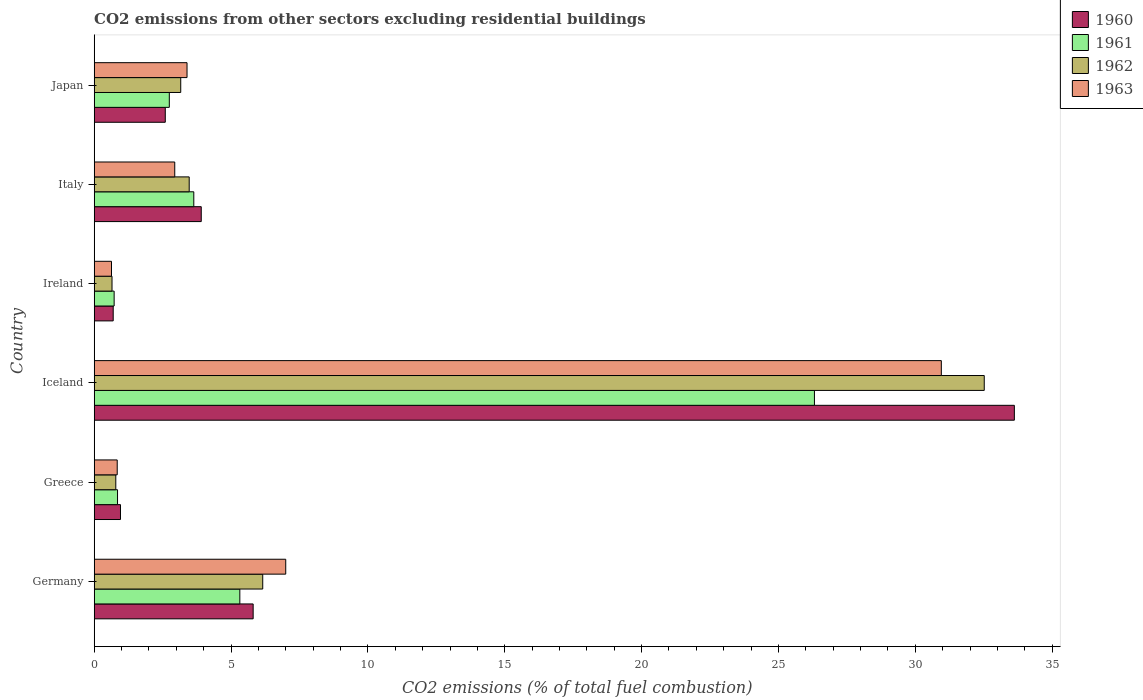How many groups of bars are there?
Keep it short and to the point. 6. Are the number of bars per tick equal to the number of legend labels?
Ensure brevity in your answer.  Yes. Are the number of bars on each tick of the Y-axis equal?
Give a very brief answer. Yes. How many bars are there on the 2nd tick from the top?
Give a very brief answer. 4. How many bars are there on the 2nd tick from the bottom?
Provide a succinct answer. 4. What is the label of the 4th group of bars from the top?
Keep it short and to the point. Iceland. What is the total CO2 emitted in 1962 in Greece?
Keep it short and to the point. 0.79. Across all countries, what is the maximum total CO2 emitted in 1960?
Your answer should be very brief. 33.62. Across all countries, what is the minimum total CO2 emitted in 1963?
Keep it short and to the point. 0.63. In which country was the total CO2 emitted in 1961 minimum?
Ensure brevity in your answer.  Ireland. What is the total total CO2 emitted in 1963 in the graph?
Your answer should be very brief. 45.76. What is the difference between the total CO2 emitted in 1961 in Greece and that in Italy?
Make the answer very short. -2.79. What is the difference between the total CO2 emitted in 1961 in Greece and the total CO2 emitted in 1962 in Germany?
Ensure brevity in your answer.  -5.31. What is the average total CO2 emitted in 1962 per country?
Offer a very short reply. 7.79. What is the difference between the total CO2 emitted in 1960 and total CO2 emitted in 1963 in Ireland?
Your answer should be very brief. 0.06. What is the ratio of the total CO2 emitted in 1962 in Greece to that in Japan?
Offer a terse response. 0.25. Is the difference between the total CO2 emitted in 1960 in Germany and Greece greater than the difference between the total CO2 emitted in 1963 in Germany and Greece?
Provide a succinct answer. No. What is the difference between the highest and the second highest total CO2 emitted in 1960?
Ensure brevity in your answer.  27.81. What is the difference between the highest and the lowest total CO2 emitted in 1961?
Offer a very short reply. 25.59. Is the sum of the total CO2 emitted in 1963 in Ireland and Japan greater than the maximum total CO2 emitted in 1962 across all countries?
Give a very brief answer. No. Is it the case that in every country, the sum of the total CO2 emitted in 1962 and total CO2 emitted in 1963 is greater than the sum of total CO2 emitted in 1961 and total CO2 emitted in 1960?
Offer a very short reply. No. What does the 4th bar from the top in Ireland represents?
Your answer should be compact. 1960. Is it the case that in every country, the sum of the total CO2 emitted in 1961 and total CO2 emitted in 1962 is greater than the total CO2 emitted in 1963?
Offer a very short reply. Yes. Are all the bars in the graph horizontal?
Make the answer very short. Yes. Are the values on the major ticks of X-axis written in scientific E-notation?
Provide a succinct answer. No. Does the graph contain any zero values?
Your answer should be very brief. No. Where does the legend appear in the graph?
Provide a short and direct response. Top right. How many legend labels are there?
Provide a short and direct response. 4. How are the legend labels stacked?
Make the answer very short. Vertical. What is the title of the graph?
Your answer should be very brief. CO2 emissions from other sectors excluding residential buildings. Does "1988" appear as one of the legend labels in the graph?
Make the answer very short. No. What is the label or title of the X-axis?
Your answer should be very brief. CO2 emissions (% of total fuel combustion). What is the label or title of the Y-axis?
Offer a terse response. Country. What is the CO2 emissions (% of total fuel combustion) in 1960 in Germany?
Provide a short and direct response. 5.81. What is the CO2 emissions (% of total fuel combustion) of 1961 in Germany?
Provide a short and direct response. 5.32. What is the CO2 emissions (% of total fuel combustion) in 1962 in Germany?
Provide a short and direct response. 6.16. What is the CO2 emissions (% of total fuel combustion) of 1963 in Germany?
Ensure brevity in your answer.  7. What is the CO2 emissions (% of total fuel combustion) of 1960 in Greece?
Provide a short and direct response. 0.96. What is the CO2 emissions (% of total fuel combustion) in 1961 in Greece?
Your answer should be very brief. 0.85. What is the CO2 emissions (% of total fuel combustion) in 1962 in Greece?
Your response must be concise. 0.79. What is the CO2 emissions (% of total fuel combustion) of 1963 in Greece?
Ensure brevity in your answer.  0.84. What is the CO2 emissions (% of total fuel combustion) of 1960 in Iceland?
Provide a succinct answer. 33.62. What is the CO2 emissions (% of total fuel combustion) of 1961 in Iceland?
Keep it short and to the point. 26.32. What is the CO2 emissions (% of total fuel combustion) of 1962 in Iceland?
Your answer should be very brief. 32.52. What is the CO2 emissions (% of total fuel combustion) of 1963 in Iceland?
Make the answer very short. 30.95. What is the CO2 emissions (% of total fuel combustion) in 1960 in Ireland?
Your answer should be compact. 0.69. What is the CO2 emissions (% of total fuel combustion) of 1961 in Ireland?
Your response must be concise. 0.73. What is the CO2 emissions (% of total fuel combustion) of 1962 in Ireland?
Keep it short and to the point. 0.65. What is the CO2 emissions (% of total fuel combustion) of 1963 in Ireland?
Your answer should be very brief. 0.63. What is the CO2 emissions (% of total fuel combustion) in 1960 in Italy?
Your answer should be compact. 3.91. What is the CO2 emissions (% of total fuel combustion) in 1961 in Italy?
Make the answer very short. 3.64. What is the CO2 emissions (% of total fuel combustion) of 1962 in Italy?
Offer a terse response. 3.47. What is the CO2 emissions (% of total fuel combustion) in 1963 in Italy?
Make the answer very short. 2.94. What is the CO2 emissions (% of total fuel combustion) in 1960 in Japan?
Provide a short and direct response. 2.6. What is the CO2 emissions (% of total fuel combustion) in 1961 in Japan?
Offer a very short reply. 2.74. What is the CO2 emissions (% of total fuel combustion) of 1962 in Japan?
Provide a short and direct response. 3.16. What is the CO2 emissions (% of total fuel combustion) in 1963 in Japan?
Keep it short and to the point. 3.39. Across all countries, what is the maximum CO2 emissions (% of total fuel combustion) in 1960?
Make the answer very short. 33.62. Across all countries, what is the maximum CO2 emissions (% of total fuel combustion) in 1961?
Offer a very short reply. 26.32. Across all countries, what is the maximum CO2 emissions (% of total fuel combustion) of 1962?
Make the answer very short. 32.52. Across all countries, what is the maximum CO2 emissions (% of total fuel combustion) in 1963?
Keep it short and to the point. 30.95. Across all countries, what is the minimum CO2 emissions (% of total fuel combustion) of 1960?
Give a very brief answer. 0.69. Across all countries, what is the minimum CO2 emissions (% of total fuel combustion) of 1961?
Your answer should be very brief. 0.73. Across all countries, what is the minimum CO2 emissions (% of total fuel combustion) in 1962?
Provide a short and direct response. 0.65. Across all countries, what is the minimum CO2 emissions (% of total fuel combustion) of 1963?
Your answer should be very brief. 0.63. What is the total CO2 emissions (% of total fuel combustion) in 1960 in the graph?
Ensure brevity in your answer.  47.59. What is the total CO2 emissions (% of total fuel combustion) of 1961 in the graph?
Your answer should be compact. 39.6. What is the total CO2 emissions (% of total fuel combustion) of 1962 in the graph?
Give a very brief answer. 46.75. What is the total CO2 emissions (% of total fuel combustion) of 1963 in the graph?
Provide a short and direct response. 45.76. What is the difference between the CO2 emissions (% of total fuel combustion) of 1960 in Germany and that in Greece?
Ensure brevity in your answer.  4.85. What is the difference between the CO2 emissions (% of total fuel combustion) of 1961 in Germany and that in Greece?
Provide a short and direct response. 4.47. What is the difference between the CO2 emissions (% of total fuel combustion) in 1962 in Germany and that in Greece?
Ensure brevity in your answer.  5.37. What is the difference between the CO2 emissions (% of total fuel combustion) in 1963 in Germany and that in Greece?
Give a very brief answer. 6.16. What is the difference between the CO2 emissions (% of total fuel combustion) of 1960 in Germany and that in Iceland?
Offer a terse response. -27.81. What is the difference between the CO2 emissions (% of total fuel combustion) in 1961 in Germany and that in Iceland?
Make the answer very short. -20.99. What is the difference between the CO2 emissions (% of total fuel combustion) in 1962 in Germany and that in Iceland?
Your answer should be very brief. -26.36. What is the difference between the CO2 emissions (% of total fuel combustion) of 1963 in Germany and that in Iceland?
Your answer should be compact. -23.95. What is the difference between the CO2 emissions (% of total fuel combustion) of 1960 in Germany and that in Ireland?
Your answer should be compact. 5.11. What is the difference between the CO2 emissions (% of total fuel combustion) of 1961 in Germany and that in Ireland?
Provide a short and direct response. 4.59. What is the difference between the CO2 emissions (% of total fuel combustion) in 1962 in Germany and that in Ireland?
Give a very brief answer. 5.51. What is the difference between the CO2 emissions (% of total fuel combustion) of 1963 in Germany and that in Ireland?
Your answer should be very brief. 6.37. What is the difference between the CO2 emissions (% of total fuel combustion) of 1960 in Germany and that in Italy?
Offer a very short reply. 1.9. What is the difference between the CO2 emissions (% of total fuel combustion) of 1961 in Germany and that in Italy?
Give a very brief answer. 1.68. What is the difference between the CO2 emissions (% of total fuel combustion) in 1962 in Germany and that in Italy?
Your response must be concise. 2.69. What is the difference between the CO2 emissions (% of total fuel combustion) in 1963 in Germany and that in Italy?
Offer a very short reply. 4.05. What is the difference between the CO2 emissions (% of total fuel combustion) of 1960 in Germany and that in Japan?
Offer a very short reply. 3.21. What is the difference between the CO2 emissions (% of total fuel combustion) of 1961 in Germany and that in Japan?
Keep it short and to the point. 2.58. What is the difference between the CO2 emissions (% of total fuel combustion) in 1962 in Germany and that in Japan?
Provide a short and direct response. 3. What is the difference between the CO2 emissions (% of total fuel combustion) in 1963 in Germany and that in Japan?
Offer a very short reply. 3.61. What is the difference between the CO2 emissions (% of total fuel combustion) in 1960 in Greece and that in Iceland?
Keep it short and to the point. -32.66. What is the difference between the CO2 emissions (% of total fuel combustion) of 1961 in Greece and that in Iceland?
Offer a terse response. -25.46. What is the difference between the CO2 emissions (% of total fuel combustion) in 1962 in Greece and that in Iceland?
Provide a succinct answer. -31.73. What is the difference between the CO2 emissions (% of total fuel combustion) in 1963 in Greece and that in Iceland?
Offer a terse response. -30.11. What is the difference between the CO2 emissions (% of total fuel combustion) in 1960 in Greece and that in Ireland?
Ensure brevity in your answer.  0.27. What is the difference between the CO2 emissions (% of total fuel combustion) of 1961 in Greece and that in Ireland?
Your response must be concise. 0.12. What is the difference between the CO2 emissions (% of total fuel combustion) of 1962 in Greece and that in Ireland?
Your answer should be very brief. 0.14. What is the difference between the CO2 emissions (% of total fuel combustion) in 1963 in Greece and that in Ireland?
Your answer should be very brief. 0.21. What is the difference between the CO2 emissions (% of total fuel combustion) of 1960 in Greece and that in Italy?
Keep it short and to the point. -2.95. What is the difference between the CO2 emissions (% of total fuel combustion) of 1961 in Greece and that in Italy?
Offer a very short reply. -2.79. What is the difference between the CO2 emissions (% of total fuel combustion) of 1962 in Greece and that in Italy?
Offer a very short reply. -2.68. What is the difference between the CO2 emissions (% of total fuel combustion) in 1963 in Greece and that in Italy?
Make the answer very short. -2.1. What is the difference between the CO2 emissions (% of total fuel combustion) of 1960 in Greece and that in Japan?
Your answer should be compact. -1.64. What is the difference between the CO2 emissions (% of total fuel combustion) of 1961 in Greece and that in Japan?
Keep it short and to the point. -1.89. What is the difference between the CO2 emissions (% of total fuel combustion) in 1962 in Greece and that in Japan?
Provide a succinct answer. -2.37. What is the difference between the CO2 emissions (% of total fuel combustion) of 1963 in Greece and that in Japan?
Make the answer very short. -2.55. What is the difference between the CO2 emissions (% of total fuel combustion) of 1960 in Iceland and that in Ireland?
Offer a very short reply. 32.93. What is the difference between the CO2 emissions (% of total fuel combustion) of 1961 in Iceland and that in Ireland?
Make the answer very short. 25.59. What is the difference between the CO2 emissions (% of total fuel combustion) of 1962 in Iceland and that in Ireland?
Your answer should be compact. 31.87. What is the difference between the CO2 emissions (% of total fuel combustion) of 1963 in Iceland and that in Ireland?
Make the answer very short. 30.32. What is the difference between the CO2 emissions (% of total fuel combustion) in 1960 in Iceland and that in Italy?
Your response must be concise. 29.71. What is the difference between the CO2 emissions (% of total fuel combustion) of 1961 in Iceland and that in Italy?
Give a very brief answer. 22.68. What is the difference between the CO2 emissions (% of total fuel combustion) of 1962 in Iceland and that in Italy?
Offer a terse response. 29.05. What is the difference between the CO2 emissions (% of total fuel combustion) of 1963 in Iceland and that in Italy?
Offer a terse response. 28.01. What is the difference between the CO2 emissions (% of total fuel combustion) of 1960 in Iceland and that in Japan?
Ensure brevity in your answer.  31.02. What is the difference between the CO2 emissions (% of total fuel combustion) of 1961 in Iceland and that in Japan?
Offer a very short reply. 23.57. What is the difference between the CO2 emissions (% of total fuel combustion) in 1962 in Iceland and that in Japan?
Your answer should be compact. 29.36. What is the difference between the CO2 emissions (% of total fuel combustion) of 1963 in Iceland and that in Japan?
Your response must be concise. 27.56. What is the difference between the CO2 emissions (% of total fuel combustion) of 1960 in Ireland and that in Italy?
Offer a very short reply. -3.22. What is the difference between the CO2 emissions (% of total fuel combustion) of 1961 in Ireland and that in Italy?
Provide a short and direct response. -2.91. What is the difference between the CO2 emissions (% of total fuel combustion) of 1962 in Ireland and that in Italy?
Your response must be concise. -2.82. What is the difference between the CO2 emissions (% of total fuel combustion) of 1963 in Ireland and that in Italy?
Make the answer very short. -2.31. What is the difference between the CO2 emissions (% of total fuel combustion) of 1960 in Ireland and that in Japan?
Make the answer very short. -1.9. What is the difference between the CO2 emissions (% of total fuel combustion) in 1961 in Ireland and that in Japan?
Your response must be concise. -2.02. What is the difference between the CO2 emissions (% of total fuel combustion) in 1962 in Ireland and that in Japan?
Offer a very short reply. -2.51. What is the difference between the CO2 emissions (% of total fuel combustion) of 1963 in Ireland and that in Japan?
Make the answer very short. -2.76. What is the difference between the CO2 emissions (% of total fuel combustion) of 1960 in Italy and that in Japan?
Provide a short and direct response. 1.31. What is the difference between the CO2 emissions (% of total fuel combustion) of 1961 in Italy and that in Japan?
Your answer should be compact. 0.89. What is the difference between the CO2 emissions (% of total fuel combustion) of 1962 in Italy and that in Japan?
Provide a succinct answer. 0.31. What is the difference between the CO2 emissions (% of total fuel combustion) in 1963 in Italy and that in Japan?
Ensure brevity in your answer.  -0.45. What is the difference between the CO2 emissions (% of total fuel combustion) of 1960 in Germany and the CO2 emissions (% of total fuel combustion) of 1961 in Greece?
Offer a very short reply. 4.96. What is the difference between the CO2 emissions (% of total fuel combustion) of 1960 in Germany and the CO2 emissions (% of total fuel combustion) of 1962 in Greece?
Give a very brief answer. 5.02. What is the difference between the CO2 emissions (% of total fuel combustion) of 1960 in Germany and the CO2 emissions (% of total fuel combustion) of 1963 in Greece?
Offer a terse response. 4.97. What is the difference between the CO2 emissions (% of total fuel combustion) of 1961 in Germany and the CO2 emissions (% of total fuel combustion) of 1962 in Greece?
Keep it short and to the point. 4.53. What is the difference between the CO2 emissions (% of total fuel combustion) of 1961 in Germany and the CO2 emissions (% of total fuel combustion) of 1963 in Greece?
Make the answer very short. 4.48. What is the difference between the CO2 emissions (% of total fuel combustion) of 1962 in Germany and the CO2 emissions (% of total fuel combustion) of 1963 in Greece?
Your response must be concise. 5.32. What is the difference between the CO2 emissions (% of total fuel combustion) of 1960 in Germany and the CO2 emissions (% of total fuel combustion) of 1961 in Iceland?
Provide a short and direct response. -20.51. What is the difference between the CO2 emissions (% of total fuel combustion) in 1960 in Germany and the CO2 emissions (% of total fuel combustion) in 1962 in Iceland?
Provide a succinct answer. -26.71. What is the difference between the CO2 emissions (% of total fuel combustion) in 1960 in Germany and the CO2 emissions (% of total fuel combustion) in 1963 in Iceland?
Provide a succinct answer. -25.14. What is the difference between the CO2 emissions (% of total fuel combustion) of 1961 in Germany and the CO2 emissions (% of total fuel combustion) of 1962 in Iceland?
Your answer should be very brief. -27.2. What is the difference between the CO2 emissions (% of total fuel combustion) of 1961 in Germany and the CO2 emissions (% of total fuel combustion) of 1963 in Iceland?
Offer a very short reply. -25.63. What is the difference between the CO2 emissions (% of total fuel combustion) in 1962 in Germany and the CO2 emissions (% of total fuel combustion) in 1963 in Iceland?
Provide a short and direct response. -24.79. What is the difference between the CO2 emissions (% of total fuel combustion) of 1960 in Germany and the CO2 emissions (% of total fuel combustion) of 1961 in Ireland?
Provide a short and direct response. 5.08. What is the difference between the CO2 emissions (% of total fuel combustion) in 1960 in Germany and the CO2 emissions (% of total fuel combustion) in 1962 in Ireland?
Make the answer very short. 5.16. What is the difference between the CO2 emissions (% of total fuel combustion) of 1960 in Germany and the CO2 emissions (% of total fuel combustion) of 1963 in Ireland?
Keep it short and to the point. 5.18. What is the difference between the CO2 emissions (% of total fuel combustion) of 1961 in Germany and the CO2 emissions (% of total fuel combustion) of 1962 in Ireland?
Offer a very short reply. 4.67. What is the difference between the CO2 emissions (% of total fuel combustion) in 1961 in Germany and the CO2 emissions (% of total fuel combustion) in 1963 in Ireland?
Offer a terse response. 4.69. What is the difference between the CO2 emissions (% of total fuel combustion) in 1962 in Germany and the CO2 emissions (% of total fuel combustion) in 1963 in Ireland?
Ensure brevity in your answer.  5.53. What is the difference between the CO2 emissions (% of total fuel combustion) of 1960 in Germany and the CO2 emissions (% of total fuel combustion) of 1961 in Italy?
Make the answer very short. 2.17. What is the difference between the CO2 emissions (% of total fuel combustion) of 1960 in Germany and the CO2 emissions (% of total fuel combustion) of 1962 in Italy?
Provide a short and direct response. 2.34. What is the difference between the CO2 emissions (% of total fuel combustion) of 1960 in Germany and the CO2 emissions (% of total fuel combustion) of 1963 in Italy?
Ensure brevity in your answer.  2.86. What is the difference between the CO2 emissions (% of total fuel combustion) of 1961 in Germany and the CO2 emissions (% of total fuel combustion) of 1962 in Italy?
Your response must be concise. 1.85. What is the difference between the CO2 emissions (% of total fuel combustion) of 1961 in Germany and the CO2 emissions (% of total fuel combustion) of 1963 in Italy?
Your answer should be very brief. 2.38. What is the difference between the CO2 emissions (% of total fuel combustion) of 1962 in Germany and the CO2 emissions (% of total fuel combustion) of 1963 in Italy?
Offer a very short reply. 3.21. What is the difference between the CO2 emissions (% of total fuel combustion) in 1960 in Germany and the CO2 emissions (% of total fuel combustion) in 1961 in Japan?
Ensure brevity in your answer.  3.06. What is the difference between the CO2 emissions (% of total fuel combustion) in 1960 in Germany and the CO2 emissions (% of total fuel combustion) in 1962 in Japan?
Keep it short and to the point. 2.65. What is the difference between the CO2 emissions (% of total fuel combustion) in 1960 in Germany and the CO2 emissions (% of total fuel combustion) in 1963 in Japan?
Your answer should be very brief. 2.42. What is the difference between the CO2 emissions (% of total fuel combustion) of 1961 in Germany and the CO2 emissions (% of total fuel combustion) of 1962 in Japan?
Make the answer very short. 2.16. What is the difference between the CO2 emissions (% of total fuel combustion) in 1961 in Germany and the CO2 emissions (% of total fuel combustion) in 1963 in Japan?
Your answer should be compact. 1.93. What is the difference between the CO2 emissions (% of total fuel combustion) in 1962 in Germany and the CO2 emissions (% of total fuel combustion) in 1963 in Japan?
Give a very brief answer. 2.77. What is the difference between the CO2 emissions (% of total fuel combustion) of 1960 in Greece and the CO2 emissions (% of total fuel combustion) of 1961 in Iceland?
Make the answer very short. -25.36. What is the difference between the CO2 emissions (% of total fuel combustion) of 1960 in Greece and the CO2 emissions (% of total fuel combustion) of 1962 in Iceland?
Provide a short and direct response. -31.56. What is the difference between the CO2 emissions (% of total fuel combustion) of 1960 in Greece and the CO2 emissions (% of total fuel combustion) of 1963 in Iceland?
Provide a succinct answer. -29.99. What is the difference between the CO2 emissions (% of total fuel combustion) in 1961 in Greece and the CO2 emissions (% of total fuel combustion) in 1962 in Iceland?
Make the answer very short. -31.67. What is the difference between the CO2 emissions (% of total fuel combustion) in 1961 in Greece and the CO2 emissions (% of total fuel combustion) in 1963 in Iceland?
Offer a very short reply. -30.1. What is the difference between the CO2 emissions (% of total fuel combustion) in 1962 in Greece and the CO2 emissions (% of total fuel combustion) in 1963 in Iceland?
Keep it short and to the point. -30.16. What is the difference between the CO2 emissions (% of total fuel combustion) in 1960 in Greece and the CO2 emissions (% of total fuel combustion) in 1961 in Ireland?
Keep it short and to the point. 0.23. What is the difference between the CO2 emissions (% of total fuel combustion) in 1960 in Greece and the CO2 emissions (% of total fuel combustion) in 1962 in Ireland?
Offer a very short reply. 0.31. What is the difference between the CO2 emissions (% of total fuel combustion) in 1960 in Greece and the CO2 emissions (% of total fuel combustion) in 1963 in Ireland?
Make the answer very short. 0.33. What is the difference between the CO2 emissions (% of total fuel combustion) in 1961 in Greece and the CO2 emissions (% of total fuel combustion) in 1962 in Ireland?
Keep it short and to the point. 0.2. What is the difference between the CO2 emissions (% of total fuel combustion) of 1961 in Greece and the CO2 emissions (% of total fuel combustion) of 1963 in Ireland?
Provide a succinct answer. 0.22. What is the difference between the CO2 emissions (% of total fuel combustion) of 1962 in Greece and the CO2 emissions (% of total fuel combustion) of 1963 in Ireland?
Ensure brevity in your answer.  0.16. What is the difference between the CO2 emissions (% of total fuel combustion) in 1960 in Greece and the CO2 emissions (% of total fuel combustion) in 1961 in Italy?
Provide a succinct answer. -2.68. What is the difference between the CO2 emissions (% of total fuel combustion) of 1960 in Greece and the CO2 emissions (% of total fuel combustion) of 1962 in Italy?
Ensure brevity in your answer.  -2.51. What is the difference between the CO2 emissions (% of total fuel combustion) in 1960 in Greece and the CO2 emissions (% of total fuel combustion) in 1963 in Italy?
Make the answer very short. -1.98. What is the difference between the CO2 emissions (% of total fuel combustion) in 1961 in Greece and the CO2 emissions (% of total fuel combustion) in 1962 in Italy?
Offer a terse response. -2.62. What is the difference between the CO2 emissions (% of total fuel combustion) in 1961 in Greece and the CO2 emissions (% of total fuel combustion) in 1963 in Italy?
Keep it short and to the point. -2.09. What is the difference between the CO2 emissions (% of total fuel combustion) in 1962 in Greece and the CO2 emissions (% of total fuel combustion) in 1963 in Italy?
Provide a succinct answer. -2.15. What is the difference between the CO2 emissions (% of total fuel combustion) of 1960 in Greece and the CO2 emissions (% of total fuel combustion) of 1961 in Japan?
Ensure brevity in your answer.  -1.78. What is the difference between the CO2 emissions (% of total fuel combustion) of 1960 in Greece and the CO2 emissions (% of total fuel combustion) of 1962 in Japan?
Make the answer very short. -2.2. What is the difference between the CO2 emissions (% of total fuel combustion) of 1960 in Greece and the CO2 emissions (% of total fuel combustion) of 1963 in Japan?
Keep it short and to the point. -2.43. What is the difference between the CO2 emissions (% of total fuel combustion) of 1961 in Greece and the CO2 emissions (% of total fuel combustion) of 1962 in Japan?
Offer a very short reply. -2.31. What is the difference between the CO2 emissions (% of total fuel combustion) in 1961 in Greece and the CO2 emissions (% of total fuel combustion) in 1963 in Japan?
Your answer should be compact. -2.54. What is the difference between the CO2 emissions (% of total fuel combustion) in 1962 in Greece and the CO2 emissions (% of total fuel combustion) in 1963 in Japan?
Give a very brief answer. -2.6. What is the difference between the CO2 emissions (% of total fuel combustion) of 1960 in Iceland and the CO2 emissions (% of total fuel combustion) of 1961 in Ireland?
Provide a short and direct response. 32.89. What is the difference between the CO2 emissions (% of total fuel combustion) of 1960 in Iceland and the CO2 emissions (% of total fuel combustion) of 1962 in Ireland?
Keep it short and to the point. 32.97. What is the difference between the CO2 emissions (% of total fuel combustion) of 1960 in Iceland and the CO2 emissions (% of total fuel combustion) of 1963 in Ireland?
Offer a very short reply. 32.99. What is the difference between the CO2 emissions (% of total fuel combustion) in 1961 in Iceland and the CO2 emissions (% of total fuel combustion) in 1962 in Ireland?
Give a very brief answer. 25.66. What is the difference between the CO2 emissions (% of total fuel combustion) in 1961 in Iceland and the CO2 emissions (% of total fuel combustion) in 1963 in Ireland?
Give a very brief answer. 25.68. What is the difference between the CO2 emissions (% of total fuel combustion) in 1962 in Iceland and the CO2 emissions (% of total fuel combustion) in 1963 in Ireland?
Provide a succinct answer. 31.89. What is the difference between the CO2 emissions (% of total fuel combustion) in 1960 in Iceland and the CO2 emissions (% of total fuel combustion) in 1961 in Italy?
Provide a succinct answer. 29.98. What is the difference between the CO2 emissions (% of total fuel combustion) in 1960 in Iceland and the CO2 emissions (% of total fuel combustion) in 1962 in Italy?
Provide a short and direct response. 30.15. What is the difference between the CO2 emissions (% of total fuel combustion) of 1960 in Iceland and the CO2 emissions (% of total fuel combustion) of 1963 in Italy?
Offer a very short reply. 30.68. What is the difference between the CO2 emissions (% of total fuel combustion) of 1961 in Iceland and the CO2 emissions (% of total fuel combustion) of 1962 in Italy?
Provide a succinct answer. 22.84. What is the difference between the CO2 emissions (% of total fuel combustion) in 1961 in Iceland and the CO2 emissions (% of total fuel combustion) in 1963 in Italy?
Offer a terse response. 23.37. What is the difference between the CO2 emissions (% of total fuel combustion) of 1962 in Iceland and the CO2 emissions (% of total fuel combustion) of 1963 in Italy?
Provide a succinct answer. 29.58. What is the difference between the CO2 emissions (% of total fuel combustion) of 1960 in Iceland and the CO2 emissions (% of total fuel combustion) of 1961 in Japan?
Make the answer very short. 30.88. What is the difference between the CO2 emissions (% of total fuel combustion) of 1960 in Iceland and the CO2 emissions (% of total fuel combustion) of 1962 in Japan?
Make the answer very short. 30.46. What is the difference between the CO2 emissions (% of total fuel combustion) of 1960 in Iceland and the CO2 emissions (% of total fuel combustion) of 1963 in Japan?
Ensure brevity in your answer.  30.23. What is the difference between the CO2 emissions (% of total fuel combustion) in 1961 in Iceland and the CO2 emissions (% of total fuel combustion) in 1962 in Japan?
Offer a very short reply. 23.15. What is the difference between the CO2 emissions (% of total fuel combustion) in 1961 in Iceland and the CO2 emissions (% of total fuel combustion) in 1963 in Japan?
Your answer should be very brief. 22.92. What is the difference between the CO2 emissions (% of total fuel combustion) of 1962 in Iceland and the CO2 emissions (% of total fuel combustion) of 1963 in Japan?
Offer a terse response. 29.13. What is the difference between the CO2 emissions (% of total fuel combustion) of 1960 in Ireland and the CO2 emissions (% of total fuel combustion) of 1961 in Italy?
Offer a very short reply. -2.94. What is the difference between the CO2 emissions (% of total fuel combustion) in 1960 in Ireland and the CO2 emissions (% of total fuel combustion) in 1962 in Italy?
Offer a terse response. -2.78. What is the difference between the CO2 emissions (% of total fuel combustion) of 1960 in Ireland and the CO2 emissions (% of total fuel combustion) of 1963 in Italy?
Ensure brevity in your answer.  -2.25. What is the difference between the CO2 emissions (% of total fuel combustion) in 1961 in Ireland and the CO2 emissions (% of total fuel combustion) in 1962 in Italy?
Make the answer very short. -2.74. What is the difference between the CO2 emissions (% of total fuel combustion) of 1961 in Ireland and the CO2 emissions (% of total fuel combustion) of 1963 in Italy?
Ensure brevity in your answer.  -2.21. What is the difference between the CO2 emissions (% of total fuel combustion) of 1962 in Ireland and the CO2 emissions (% of total fuel combustion) of 1963 in Italy?
Offer a very short reply. -2.29. What is the difference between the CO2 emissions (% of total fuel combustion) of 1960 in Ireland and the CO2 emissions (% of total fuel combustion) of 1961 in Japan?
Offer a very short reply. -2.05. What is the difference between the CO2 emissions (% of total fuel combustion) in 1960 in Ireland and the CO2 emissions (% of total fuel combustion) in 1962 in Japan?
Offer a very short reply. -2.47. What is the difference between the CO2 emissions (% of total fuel combustion) in 1960 in Ireland and the CO2 emissions (% of total fuel combustion) in 1963 in Japan?
Give a very brief answer. -2.7. What is the difference between the CO2 emissions (% of total fuel combustion) of 1961 in Ireland and the CO2 emissions (% of total fuel combustion) of 1962 in Japan?
Make the answer very short. -2.43. What is the difference between the CO2 emissions (% of total fuel combustion) of 1961 in Ireland and the CO2 emissions (% of total fuel combustion) of 1963 in Japan?
Provide a succinct answer. -2.66. What is the difference between the CO2 emissions (% of total fuel combustion) of 1962 in Ireland and the CO2 emissions (% of total fuel combustion) of 1963 in Japan?
Offer a very short reply. -2.74. What is the difference between the CO2 emissions (% of total fuel combustion) in 1960 in Italy and the CO2 emissions (% of total fuel combustion) in 1961 in Japan?
Your answer should be very brief. 1.17. What is the difference between the CO2 emissions (% of total fuel combustion) in 1960 in Italy and the CO2 emissions (% of total fuel combustion) in 1962 in Japan?
Provide a succinct answer. 0.75. What is the difference between the CO2 emissions (% of total fuel combustion) in 1960 in Italy and the CO2 emissions (% of total fuel combustion) in 1963 in Japan?
Provide a succinct answer. 0.52. What is the difference between the CO2 emissions (% of total fuel combustion) of 1961 in Italy and the CO2 emissions (% of total fuel combustion) of 1962 in Japan?
Give a very brief answer. 0.48. What is the difference between the CO2 emissions (% of total fuel combustion) in 1961 in Italy and the CO2 emissions (% of total fuel combustion) in 1963 in Japan?
Your response must be concise. 0.25. What is the difference between the CO2 emissions (% of total fuel combustion) in 1962 in Italy and the CO2 emissions (% of total fuel combustion) in 1963 in Japan?
Your response must be concise. 0.08. What is the average CO2 emissions (% of total fuel combustion) of 1960 per country?
Your response must be concise. 7.93. What is the average CO2 emissions (% of total fuel combustion) in 1961 per country?
Make the answer very short. 6.6. What is the average CO2 emissions (% of total fuel combustion) of 1962 per country?
Give a very brief answer. 7.79. What is the average CO2 emissions (% of total fuel combustion) of 1963 per country?
Keep it short and to the point. 7.63. What is the difference between the CO2 emissions (% of total fuel combustion) of 1960 and CO2 emissions (% of total fuel combustion) of 1961 in Germany?
Your response must be concise. 0.49. What is the difference between the CO2 emissions (% of total fuel combustion) in 1960 and CO2 emissions (% of total fuel combustion) in 1962 in Germany?
Provide a short and direct response. -0.35. What is the difference between the CO2 emissions (% of total fuel combustion) in 1960 and CO2 emissions (% of total fuel combustion) in 1963 in Germany?
Offer a terse response. -1.19. What is the difference between the CO2 emissions (% of total fuel combustion) of 1961 and CO2 emissions (% of total fuel combustion) of 1962 in Germany?
Ensure brevity in your answer.  -0.84. What is the difference between the CO2 emissions (% of total fuel combustion) in 1961 and CO2 emissions (% of total fuel combustion) in 1963 in Germany?
Your answer should be very brief. -1.68. What is the difference between the CO2 emissions (% of total fuel combustion) in 1962 and CO2 emissions (% of total fuel combustion) in 1963 in Germany?
Offer a terse response. -0.84. What is the difference between the CO2 emissions (% of total fuel combustion) of 1960 and CO2 emissions (% of total fuel combustion) of 1961 in Greece?
Make the answer very short. 0.11. What is the difference between the CO2 emissions (% of total fuel combustion) of 1960 and CO2 emissions (% of total fuel combustion) of 1962 in Greece?
Offer a terse response. 0.17. What is the difference between the CO2 emissions (% of total fuel combustion) of 1960 and CO2 emissions (% of total fuel combustion) of 1963 in Greece?
Provide a succinct answer. 0.12. What is the difference between the CO2 emissions (% of total fuel combustion) of 1961 and CO2 emissions (% of total fuel combustion) of 1962 in Greece?
Give a very brief answer. 0.06. What is the difference between the CO2 emissions (% of total fuel combustion) in 1961 and CO2 emissions (% of total fuel combustion) in 1963 in Greece?
Ensure brevity in your answer.  0.01. What is the difference between the CO2 emissions (% of total fuel combustion) in 1962 and CO2 emissions (% of total fuel combustion) in 1963 in Greece?
Make the answer very short. -0.05. What is the difference between the CO2 emissions (% of total fuel combustion) of 1960 and CO2 emissions (% of total fuel combustion) of 1961 in Iceland?
Keep it short and to the point. 7.3. What is the difference between the CO2 emissions (% of total fuel combustion) in 1960 and CO2 emissions (% of total fuel combustion) in 1962 in Iceland?
Provide a short and direct response. 1.1. What is the difference between the CO2 emissions (% of total fuel combustion) of 1960 and CO2 emissions (% of total fuel combustion) of 1963 in Iceland?
Provide a succinct answer. 2.67. What is the difference between the CO2 emissions (% of total fuel combustion) of 1961 and CO2 emissions (% of total fuel combustion) of 1962 in Iceland?
Provide a short and direct response. -6.2. What is the difference between the CO2 emissions (% of total fuel combustion) of 1961 and CO2 emissions (% of total fuel combustion) of 1963 in Iceland?
Provide a short and direct response. -4.64. What is the difference between the CO2 emissions (% of total fuel combustion) in 1962 and CO2 emissions (% of total fuel combustion) in 1963 in Iceland?
Keep it short and to the point. 1.57. What is the difference between the CO2 emissions (% of total fuel combustion) of 1960 and CO2 emissions (% of total fuel combustion) of 1961 in Ireland?
Your answer should be compact. -0.03. What is the difference between the CO2 emissions (% of total fuel combustion) in 1960 and CO2 emissions (% of total fuel combustion) in 1962 in Ireland?
Your answer should be very brief. 0.04. What is the difference between the CO2 emissions (% of total fuel combustion) of 1960 and CO2 emissions (% of total fuel combustion) of 1963 in Ireland?
Your answer should be very brief. 0.06. What is the difference between the CO2 emissions (% of total fuel combustion) of 1961 and CO2 emissions (% of total fuel combustion) of 1962 in Ireland?
Ensure brevity in your answer.  0.08. What is the difference between the CO2 emissions (% of total fuel combustion) in 1961 and CO2 emissions (% of total fuel combustion) in 1963 in Ireland?
Provide a short and direct response. 0.1. What is the difference between the CO2 emissions (% of total fuel combustion) of 1962 and CO2 emissions (% of total fuel combustion) of 1963 in Ireland?
Offer a very short reply. 0.02. What is the difference between the CO2 emissions (% of total fuel combustion) in 1960 and CO2 emissions (% of total fuel combustion) in 1961 in Italy?
Provide a short and direct response. 0.27. What is the difference between the CO2 emissions (% of total fuel combustion) of 1960 and CO2 emissions (% of total fuel combustion) of 1962 in Italy?
Offer a terse response. 0.44. What is the difference between the CO2 emissions (% of total fuel combustion) of 1961 and CO2 emissions (% of total fuel combustion) of 1962 in Italy?
Make the answer very short. 0.17. What is the difference between the CO2 emissions (% of total fuel combustion) of 1961 and CO2 emissions (% of total fuel combustion) of 1963 in Italy?
Provide a short and direct response. 0.7. What is the difference between the CO2 emissions (% of total fuel combustion) of 1962 and CO2 emissions (% of total fuel combustion) of 1963 in Italy?
Provide a succinct answer. 0.53. What is the difference between the CO2 emissions (% of total fuel combustion) of 1960 and CO2 emissions (% of total fuel combustion) of 1961 in Japan?
Your answer should be compact. -0.15. What is the difference between the CO2 emissions (% of total fuel combustion) in 1960 and CO2 emissions (% of total fuel combustion) in 1962 in Japan?
Provide a succinct answer. -0.56. What is the difference between the CO2 emissions (% of total fuel combustion) in 1960 and CO2 emissions (% of total fuel combustion) in 1963 in Japan?
Provide a succinct answer. -0.79. What is the difference between the CO2 emissions (% of total fuel combustion) in 1961 and CO2 emissions (% of total fuel combustion) in 1962 in Japan?
Make the answer very short. -0.42. What is the difference between the CO2 emissions (% of total fuel combustion) in 1961 and CO2 emissions (% of total fuel combustion) in 1963 in Japan?
Ensure brevity in your answer.  -0.65. What is the difference between the CO2 emissions (% of total fuel combustion) in 1962 and CO2 emissions (% of total fuel combustion) in 1963 in Japan?
Make the answer very short. -0.23. What is the ratio of the CO2 emissions (% of total fuel combustion) of 1960 in Germany to that in Greece?
Your answer should be very brief. 6.05. What is the ratio of the CO2 emissions (% of total fuel combustion) of 1961 in Germany to that in Greece?
Offer a very short reply. 6.24. What is the ratio of the CO2 emissions (% of total fuel combustion) of 1962 in Germany to that in Greece?
Provide a succinct answer. 7.8. What is the ratio of the CO2 emissions (% of total fuel combustion) in 1963 in Germany to that in Greece?
Offer a terse response. 8.32. What is the ratio of the CO2 emissions (% of total fuel combustion) of 1960 in Germany to that in Iceland?
Provide a short and direct response. 0.17. What is the ratio of the CO2 emissions (% of total fuel combustion) in 1961 in Germany to that in Iceland?
Give a very brief answer. 0.2. What is the ratio of the CO2 emissions (% of total fuel combustion) of 1962 in Germany to that in Iceland?
Offer a very short reply. 0.19. What is the ratio of the CO2 emissions (% of total fuel combustion) of 1963 in Germany to that in Iceland?
Ensure brevity in your answer.  0.23. What is the ratio of the CO2 emissions (% of total fuel combustion) of 1960 in Germany to that in Ireland?
Your answer should be compact. 8.36. What is the ratio of the CO2 emissions (% of total fuel combustion) of 1961 in Germany to that in Ireland?
Provide a succinct answer. 7.3. What is the ratio of the CO2 emissions (% of total fuel combustion) in 1962 in Germany to that in Ireland?
Keep it short and to the point. 9.46. What is the ratio of the CO2 emissions (% of total fuel combustion) of 1963 in Germany to that in Ireland?
Provide a succinct answer. 11.07. What is the ratio of the CO2 emissions (% of total fuel combustion) in 1960 in Germany to that in Italy?
Your answer should be compact. 1.48. What is the ratio of the CO2 emissions (% of total fuel combustion) in 1961 in Germany to that in Italy?
Provide a succinct answer. 1.46. What is the ratio of the CO2 emissions (% of total fuel combustion) in 1962 in Germany to that in Italy?
Your response must be concise. 1.77. What is the ratio of the CO2 emissions (% of total fuel combustion) of 1963 in Germany to that in Italy?
Make the answer very short. 2.38. What is the ratio of the CO2 emissions (% of total fuel combustion) of 1960 in Germany to that in Japan?
Your answer should be compact. 2.24. What is the ratio of the CO2 emissions (% of total fuel combustion) in 1961 in Germany to that in Japan?
Your answer should be compact. 1.94. What is the ratio of the CO2 emissions (% of total fuel combustion) of 1962 in Germany to that in Japan?
Provide a succinct answer. 1.95. What is the ratio of the CO2 emissions (% of total fuel combustion) of 1963 in Germany to that in Japan?
Give a very brief answer. 2.06. What is the ratio of the CO2 emissions (% of total fuel combustion) of 1960 in Greece to that in Iceland?
Make the answer very short. 0.03. What is the ratio of the CO2 emissions (% of total fuel combustion) of 1961 in Greece to that in Iceland?
Your response must be concise. 0.03. What is the ratio of the CO2 emissions (% of total fuel combustion) of 1962 in Greece to that in Iceland?
Give a very brief answer. 0.02. What is the ratio of the CO2 emissions (% of total fuel combustion) in 1963 in Greece to that in Iceland?
Provide a short and direct response. 0.03. What is the ratio of the CO2 emissions (% of total fuel combustion) of 1960 in Greece to that in Ireland?
Keep it short and to the point. 1.38. What is the ratio of the CO2 emissions (% of total fuel combustion) of 1961 in Greece to that in Ireland?
Your answer should be very brief. 1.17. What is the ratio of the CO2 emissions (% of total fuel combustion) of 1962 in Greece to that in Ireland?
Keep it short and to the point. 1.21. What is the ratio of the CO2 emissions (% of total fuel combustion) in 1963 in Greece to that in Ireland?
Provide a succinct answer. 1.33. What is the ratio of the CO2 emissions (% of total fuel combustion) in 1960 in Greece to that in Italy?
Offer a very short reply. 0.25. What is the ratio of the CO2 emissions (% of total fuel combustion) of 1961 in Greece to that in Italy?
Offer a very short reply. 0.23. What is the ratio of the CO2 emissions (% of total fuel combustion) in 1962 in Greece to that in Italy?
Your response must be concise. 0.23. What is the ratio of the CO2 emissions (% of total fuel combustion) in 1963 in Greece to that in Italy?
Ensure brevity in your answer.  0.29. What is the ratio of the CO2 emissions (% of total fuel combustion) of 1960 in Greece to that in Japan?
Keep it short and to the point. 0.37. What is the ratio of the CO2 emissions (% of total fuel combustion) in 1961 in Greece to that in Japan?
Keep it short and to the point. 0.31. What is the ratio of the CO2 emissions (% of total fuel combustion) in 1962 in Greece to that in Japan?
Offer a terse response. 0.25. What is the ratio of the CO2 emissions (% of total fuel combustion) in 1963 in Greece to that in Japan?
Keep it short and to the point. 0.25. What is the ratio of the CO2 emissions (% of total fuel combustion) of 1960 in Iceland to that in Ireland?
Provide a succinct answer. 48.41. What is the ratio of the CO2 emissions (% of total fuel combustion) of 1961 in Iceland to that in Ireland?
Offer a very short reply. 36.11. What is the ratio of the CO2 emissions (% of total fuel combustion) in 1962 in Iceland to that in Ireland?
Provide a succinct answer. 49.94. What is the ratio of the CO2 emissions (% of total fuel combustion) of 1963 in Iceland to that in Ireland?
Offer a very short reply. 48.97. What is the ratio of the CO2 emissions (% of total fuel combustion) of 1960 in Iceland to that in Italy?
Provide a succinct answer. 8.6. What is the ratio of the CO2 emissions (% of total fuel combustion) of 1961 in Iceland to that in Italy?
Your answer should be compact. 7.23. What is the ratio of the CO2 emissions (% of total fuel combustion) in 1962 in Iceland to that in Italy?
Provide a succinct answer. 9.37. What is the ratio of the CO2 emissions (% of total fuel combustion) of 1963 in Iceland to that in Italy?
Keep it short and to the point. 10.52. What is the ratio of the CO2 emissions (% of total fuel combustion) of 1960 in Iceland to that in Japan?
Your answer should be compact. 12.94. What is the ratio of the CO2 emissions (% of total fuel combustion) in 1961 in Iceland to that in Japan?
Your answer should be very brief. 9.59. What is the ratio of the CO2 emissions (% of total fuel combustion) of 1962 in Iceland to that in Japan?
Your answer should be compact. 10.29. What is the ratio of the CO2 emissions (% of total fuel combustion) in 1963 in Iceland to that in Japan?
Make the answer very short. 9.13. What is the ratio of the CO2 emissions (% of total fuel combustion) of 1960 in Ireland to that in Italy?
Provide a short and direct response. 0.18. What is the ratio of the CO2 emissions (% of total fuel combustion) of 1961 in Ireland to that in Italy?
Ensure brevity in your answer.  0.2. What is the ratio of the CO2 emissions (% of total fuel combustion) in 1962 in Ireland to that in Italy?
Provide a succinct answer. 0.19. What is the ratio of the CO2 emissions (% of total fuel combustion) of 1963 in Ireland to that in Italy?
Give a very brief answer. 0.21. What is the ratio of the CO2 emissions (% of total fuel combustion) of 1960 in Ireland to that in Japan?
Provide a short and direct response. 0.27. What is the ratio of the CO2 emissions (% of total fuel combustion) in 1961 in Ireland to that in Japan?
Your answer should be compact. 0.27. What is the ratio of the CO2 emissions (% of total fuel combustion) of 1962 in Ireland to that in Japan?
Your response must be concise. 0.21. What is the ratio of the CO2 emissions (% of total fuel combustion) of 1963 in Ireland to that in Japan?
Offer a terse response. 0.19. What is the ratio of the CO2 emissions (% of total fuel combustion) in 1960 in Italy to that in Japan?
Your answer should be very brief. 1.51. What is the ratio of the CO2 emissions (% of total fuel combustion) of 1961 in Italy to that in Japan?
Provide a short and direct response. 1.33. What is the ratio of the CO2 emissions (% of total fuel combustion) in 1962 in Italy to that in Japan?
Your response must be concise. 1.1. What is the ratio of the CO2 emissions (% of total fuel combustion) of 1963 in Italy to that in Japan?
Give a very brief answer. 0.87. What is the difference between the highest and the second highest CO2 emissions (% of total fuel combustion) of 1960?
Offer a terse response. 27.81. What is the difference between the highest and the second highest CO2 emissions (% of total fuel combustion) of 1961?
Provide a succinct answer. 20.99. What is the difference between the highest and the second highest CO2 emissions (% of total fuel combustion) in 1962?
Ensure brevity in your answer.  26.36. What is the difference between the highest and the second highest CO2 emissions (% of total fuel combustion) of 1963?
Provide a succinct answer. 23.95. What is the difference between the highest and the lowest CO2 emissions (% of total fuel combustion) in 1960?
Your response must be concise. 32.93. What is the difference between the highest and the lowest CO2 emissions (% of total fuel combustion) of 1961?
Your response must be concise. 25.59. What is the difference between the highest and the lowest CO2 emissions (% of total fuel combustion) of 1962?
Ensure brevity in your answer.  31.87. What is the difference between the highest and the lowest CO2 emissions (% of total fuel combustion) of 1963?
Give a very brief answer. 30.32. 